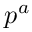Convert formula to latex. <formula><loc_0><loc_0><loc_500><loc_500>p ^ { a }</formula> 